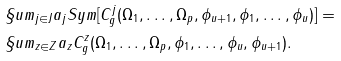<formula> <loc_0><loc_0><loc_500><loc_500>& \S u m _ { j \in J } a _ { j } S y m [ C ^ { j } _ { g } ( \Omega _ { 1 } , \dots , \Omega _ { p } , \phi _ { u + 1 } , \phi _ { 1 } , \dots , \phi _ { u } ) ] = \\ & \S u m _ { z \in Z } a _ { z } C ^ { z } _ { g } ( \Omega _ { 1 } , \dots , \Omega _ { p } , \phi _ { 1 } , \dots , \phi _ { u } , \phi _ { u + 1 } ) .</formula> 